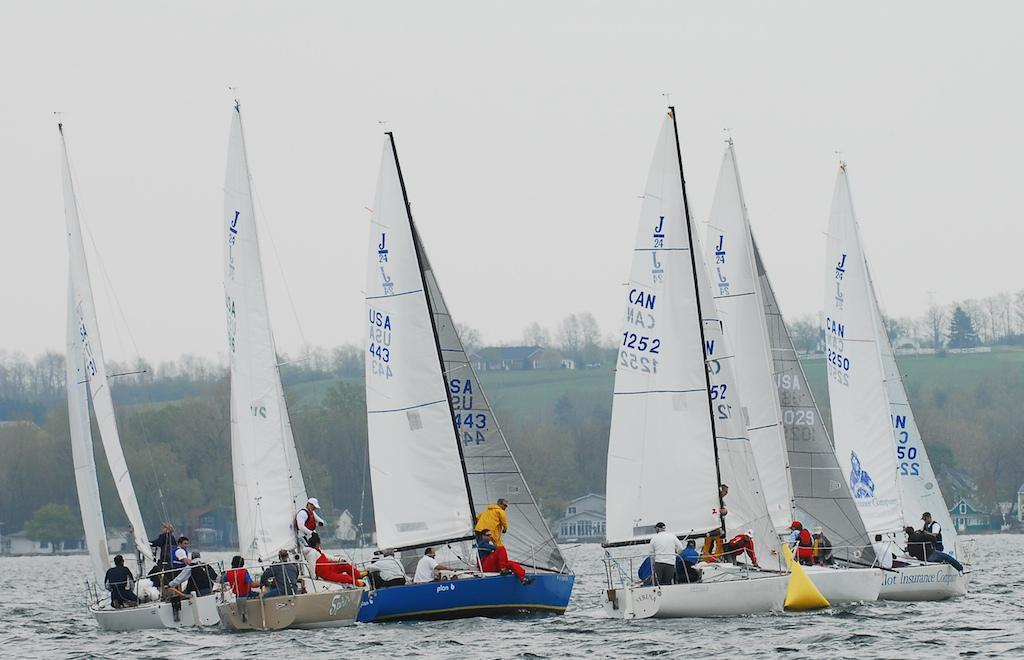<image>
Create a compact narrative representing the image presented. White sailboats say "USA" and "CAN" on the sails. 